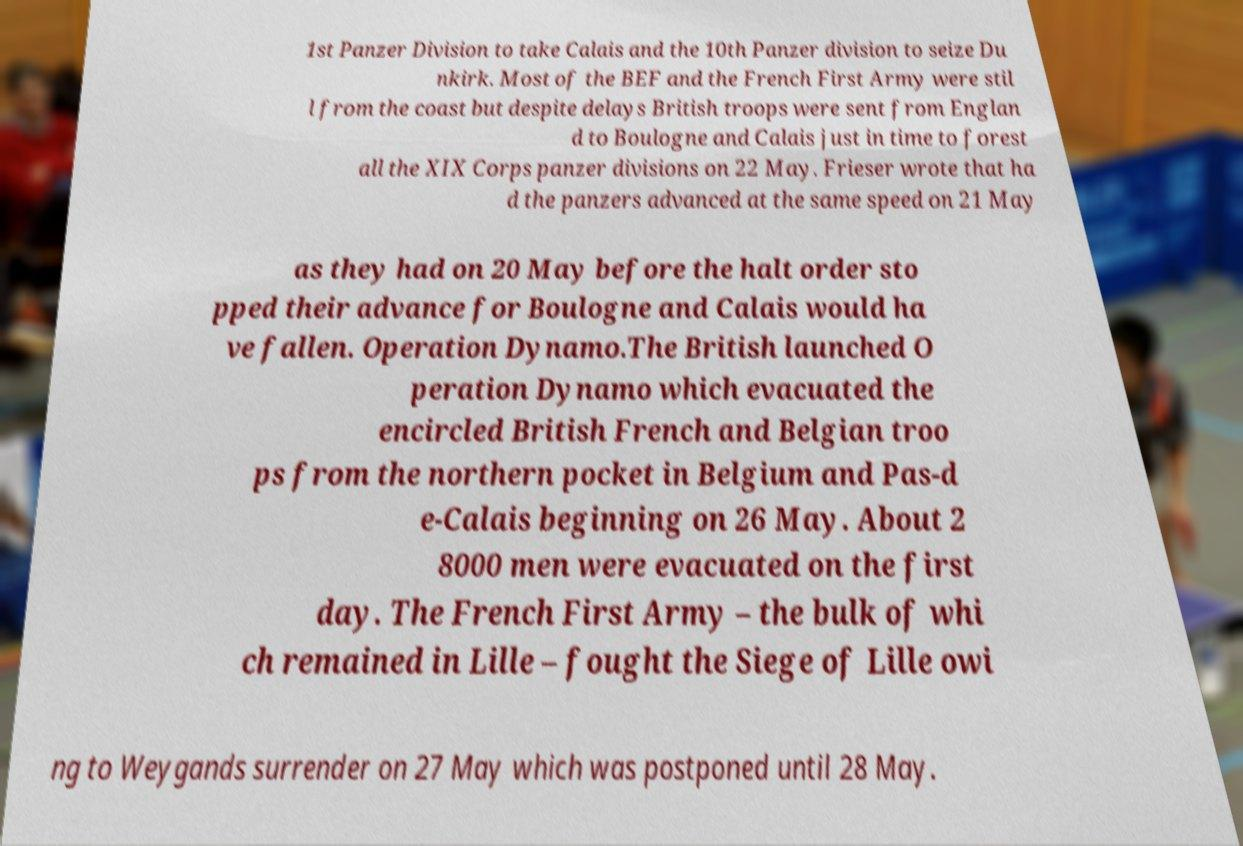Please identify and transcribe the text found in this image. 1st Panzer Division to take Calais and the 10th Panzer division to seize Du nkirk. Most of the BEF and the French First Army were stil l from the coast but despite delays British troops were sent from Englan d to Boulogne and Calais just in time to forest all the XIX Corps panzer divisions on 22 May. Frieser wrote that ha d the panzers advanced at the same speed on 21 May as they had on 20 May before the halt order sto pped their advance for Boulogne and Calais would ha ve fallen. Operation Dynamo.The British launched O peration Dynamo which evacuated the encircled British French and Belgian troo ps from the northern pocket in Belgium and Pas-d e-Calais beginning on 26 May. About 2 8000 men were evacuated on the first day. The French First Army – the bulk of whi ch remained in Lille – fought the Siege of Lille owi ng to Weygands surrender on 27 May which was postponed until 28 May. 